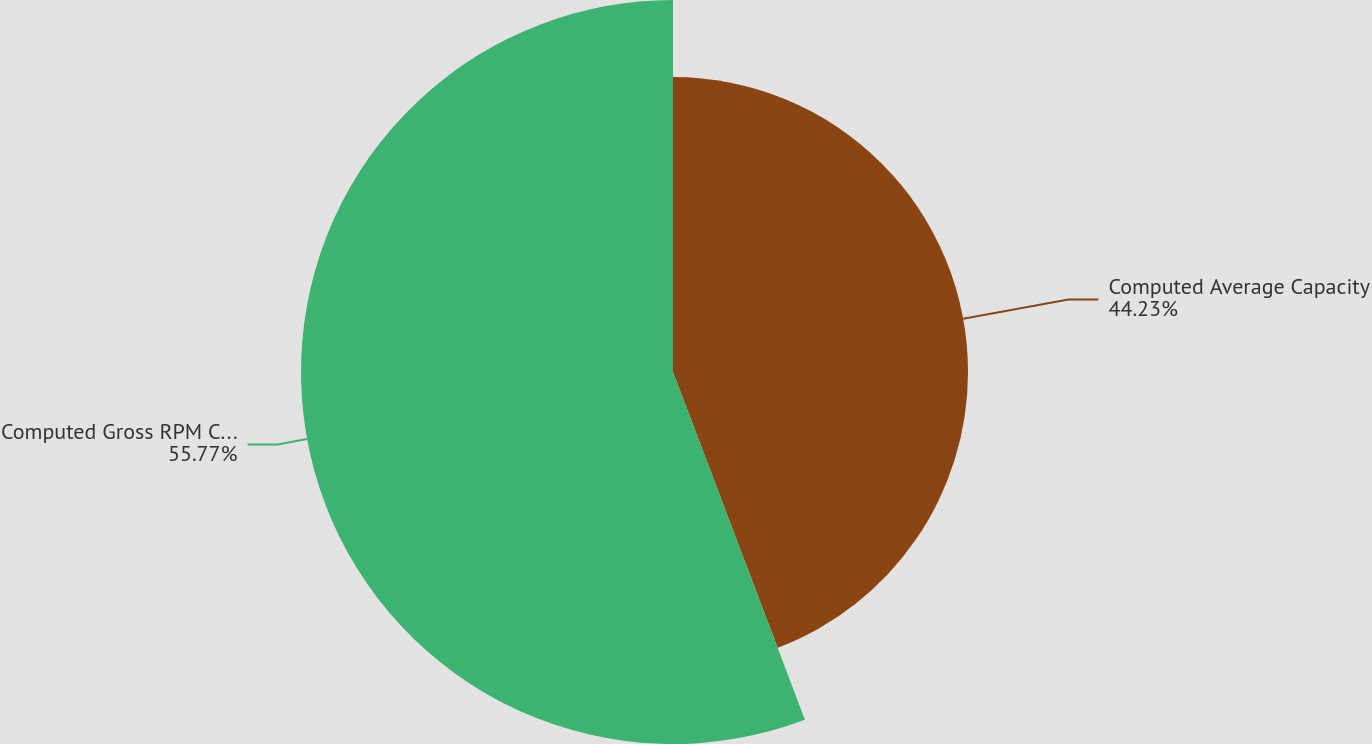<chart> <loc_0><loc_0><loc_500><loc_500><pie_chart><fcel>Computed Average Capacity<fcel>Computed Gross RPM Capacity<nl><fcel>44.23%<fcel>55.77%<nl></chart> 